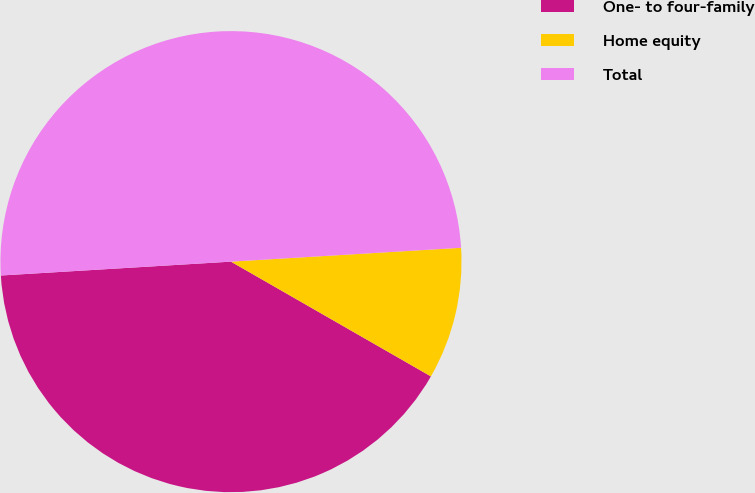<chart> <loc_0><loc_0><loc_500><loc_500><pie_chart><fcel>One- to four-family<fcel>Home equity<fcel>Total<nl><fcel>40.75%<fcel>9.25%<fcel>50.0%<nl></chart> 